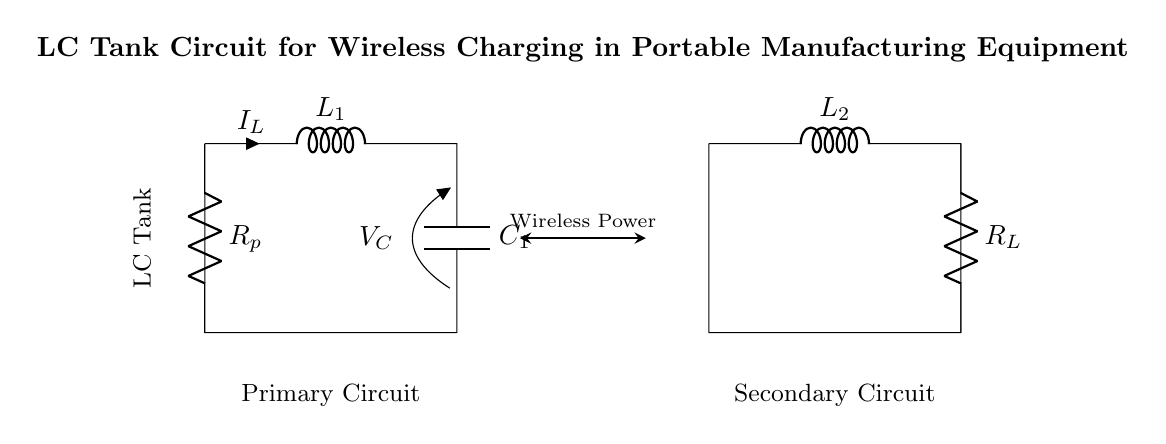What is the inductance value of the primary coil? The circuit diagram shows a component labeled L1 for the primary coil. However, the specific inductance value is not provided in the diagram. To answer this, one would typically need a reference from the specifications of the system or the components used.
Answer: Not specified What component type is represented as C1? The diagram includes a labeled component C1; this indicates a capacitor. Capacitors are components that store electrical energy temporarily in an electric field.
Answer: Capacitor What is the role of Rp in the circuit? Rp is labeled as a parasitic resistance in the diagram. It represents unwanted resistance that can dissipate energy, reducing the overall efficiency of the tank circuit.
Answer: Energy dissipation What type of circuit is this primarily considered? The circuit depicted is an LC tank circuit, which consists of inductors and capacitors resonating at a specific frequency to facilitate energy transfer. The tank circuit is associated with wireless charging applications.
Answer: LC tank circuit Which component directly connects to the load? The load is explicitly connected to the component labeled RL in the diagram. This resistor represents the resistive load that receives energy from the circuit.
Answer: RL What is the relationship between L1 and C1 in the circuit? L1 (inductor) and C1 (capacitor) together form a resonant circuit that can store and transfer energy efficiently at a particular resonant frequency. This interaction is fundamental in wireless charging systems, ensuring energy is effectively transferred.
Answer: Resonant circuit How does wireless power transfer occur in this circuit? Wireless power transfer is represented by the double-headed arrow in the diagram, indicating that energy is transferred without direct electrical connection, likely through magnetic fields created by the coils L1 and L2. This concept is integral in wireless charging applications.
Answer: Through magnetic fields 